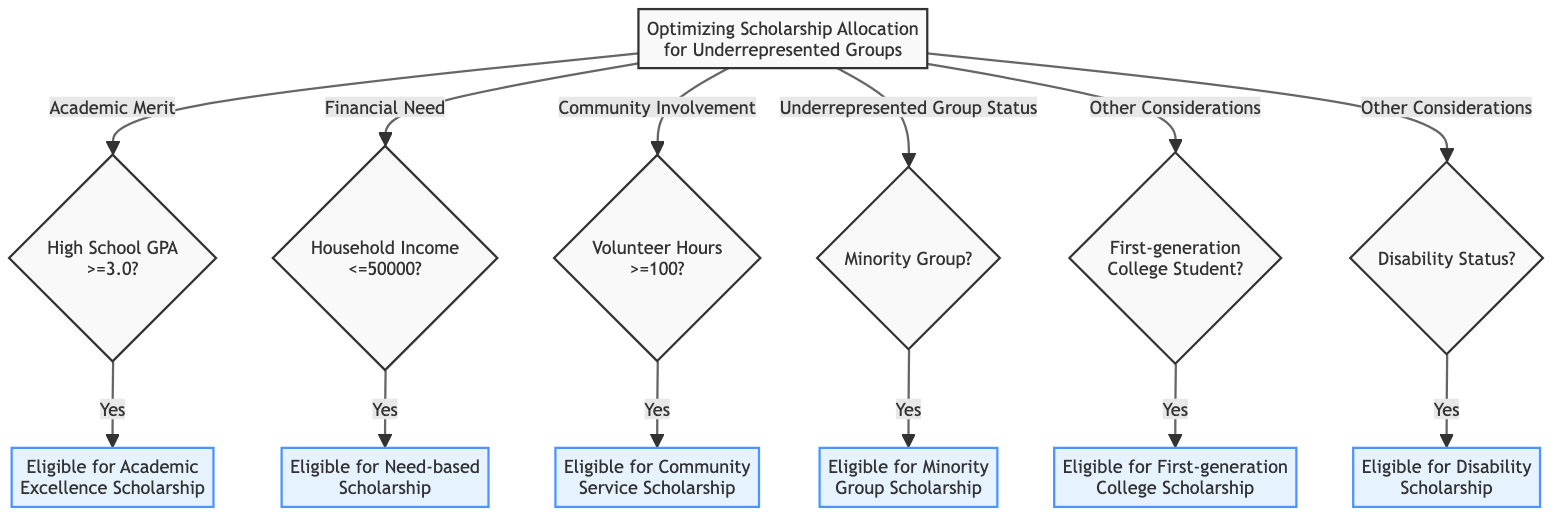What is the first criterion for scholarship allocation? The first criterion listed in the diagram is "Academic Merit", as it is directly connected to the starting point of the decision tree.
Answer: Academic Merit What condition is associated with the "Community Involvement" criterion? The condition associated with "Community Involvement" is "Volunteer Hours >=100", which leads to eligibility for the Community Service Scholarship if true.
Answer: Volunteer Hours >=100 How many results are shown in the diagram? There are six results listed in the diagram representing different scholarships awarded based on various criteria and conditions.
Answer: Six If a student qualifies for "Household Income <=50000", which scholarship are they eligible for? If a student qualifies under the condition "Household Income <=50000", they can receive the "Need-based Scholarship" as indicated by the flow in the diagram.
Answer: Need-based Scholarship What happens if a student identifies as part of a minority group? If a student identifies as part of a minority group (condition "Minority Group = Yes"), they are eligible for the "Minority Group Scholarship" as directly linked in the diagram.
Answer: Eligible for Minority Group Scholarship Which two conditions fall under "Other Considerations"? The two conditions under "Other Considerations" are "First-generation College Student" and "Disability Status", both of which lead to their respective scholarships if met.
Answer: First-generation College Student, Disability Status What scholarship is offered to students with a high GPA? Students with a high GPA (>=3.0) are eligible for the "Academic Excellence Scholarship" as specified in the diagram flow.
Answer: Academic Excellence Scholarship If a student has volunteer hours less than 100, which results can they still qualify for? If a student has fewer than 100 volunteer hours, they may still qualify for scholarships based on other criteria such as financial need or minority group status, but they cannot qualify for the Community Service Scholarship.
Answer: Depends on other criteria What is the relationship between "Disability Status" and its corresponding scholarship? The relationship is that if a student has "Disability Status = Yes", they are directly eligible for the "Disability Scholarship" as indicated in the decision path of the diagram.
Answer: Eligible for Disability Scholarship 